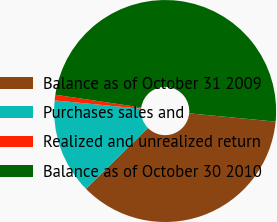Convert chart. <chart><loc_0><loc_0><loc_500><loc_500><pie_chart><fcel>Balance as of October 31 2009<fcel>Purchases sales and<fcel>Realized and unrealized return<fcel>Balance as of October 30 2010<nl><fcel>36.12%<fcel>13.88%<fcel>0.82%<fcel>49.18%<nl></chart> 